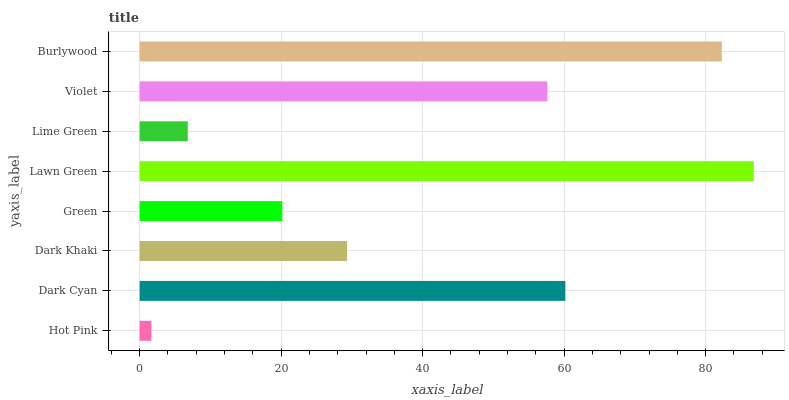Is Hot Pink the minimum?
Answer yes or no. Yes. Is Lawn Green the maximum?
Answer yes or no. Yes. Is Dark Cyan the minimum?
Answer yes or no. No. Is Dark Cyan the maximum?
Answer yes or no. No. Is Dark Cyan greater than Hot Pink?
Answer yes or no. Yes. Is Hot Pink less than Dark Cyan?
Answer yes or no. Yes. Is Hot Pink greater than Dark Cyan?
Answer yes or no. No. Is Dark Cyan less than Hot Pink?
Answer yes or no. No. Is Violet the high median?
Answer yes or no. Yes. Is Dark Khaki the low median?
Answer yes or no. Yes. Is Green the high median?
Answer yes or no. No. Is Green the low median?
Answer yes or no. No. 